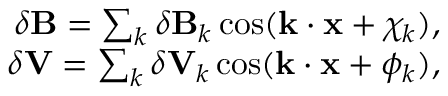<formula> <loc_0><loc_0><loc_500><loc_500>\begin{array} { r } { \delta B = \sum _ { k } \delta B _ { k } \cos ( k \cdot x + \chi _ { k } ) , } \\ { \delta V = \sum _ { k } \delta V _ { k } \cos ( k \cdot x + \phi _ { k } ) , } \end{array}</formula> 